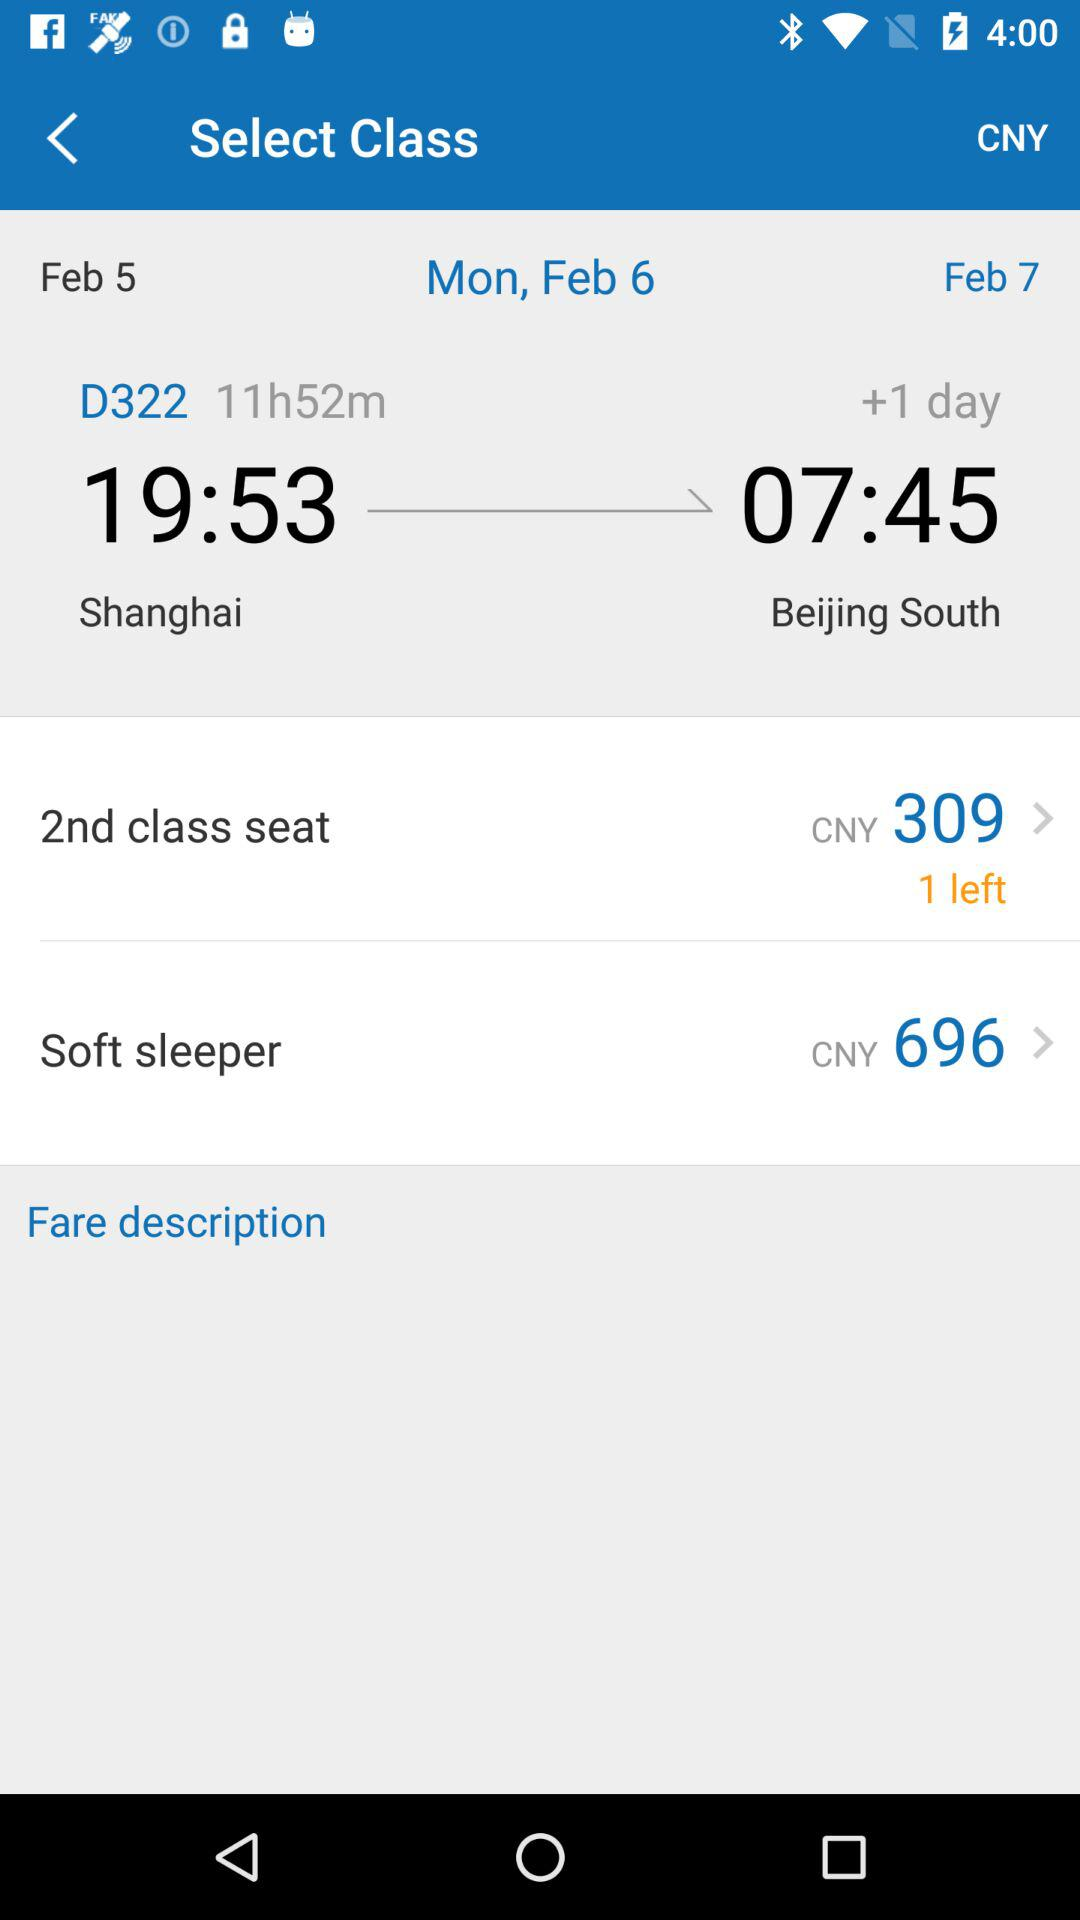What is the train number? The train number is D322. 